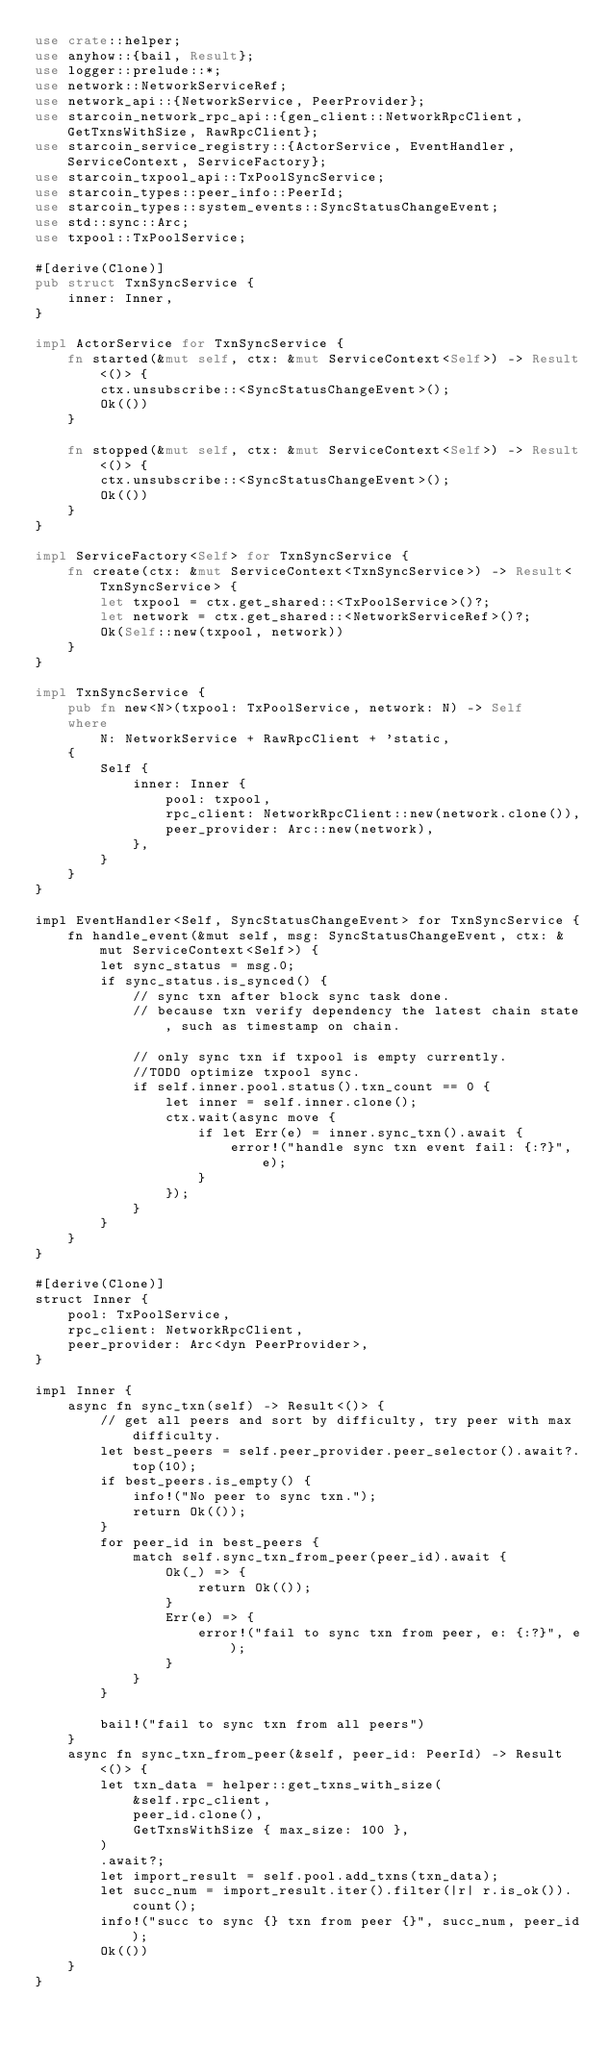<code> <loc_0><loc_0><loc_500><loc_500><_Rust_>use crate::helper;
use anyhow::{bail, Result};
use logger::prelude::*;
use network::NetworkServiceRef;
use network_api::{NetworkService, PeerProvider};
use starcoin_network_rpc_api::{gen_client::NetworkRpcClient, GetTxnsWithSize, RawRpcClient};
use starcoin_service_registry::{ActorService, EventHandler, ServiceContext, ServiceFactory};
use starcoin_txpool_api::TxPoolSyncService;
use starcoin_types::peer_info::PeerId;
use starcoin_types::system_events::SyncStatusChangeEvent;
use std::sync::Arc;
use txpool::TxPoolService;

#[derive(Clone)]
pub struct TxnSyncService {
    inner: Inner,
}

impl ActorService for TxnSyncService {
    fn started(&mut self, ctx: &mut ServiceContext<Self>) -> Result<()> {
        ctx.unsubscribe::<SyncStatusChangeEvent>();
        Ok(())
    }

    fn stopped(&mut self, ctx: &mut ServiceContext<Self>) -> Result<()> {
        ctx.unsubscribe::<SyncStatusChangeEvent>();
        Ok(())
    }
}

impl ServiceFactory<Self> for TxnSyncService {
    fn create(ctx: &mut ServiceContext<TxnSyncService>) -> Result<TxnSyncService> {
        let txpool = ctx.get_shared::<TxPoolService>()?;
        let network = ctx.get_shared::<NetworkServiceRef>()?;
        Ok(Self::new(txpool, network))
    }
}

impl TxnSyncService {
    pub fn new<N>(txpool: TxPoolService, network: N) -> Self
    where
        N: NetworkService + RawRpcClient + 'static,
    {
        Self {
            inner: Inner {
                pool: txpool,
                rpc_client: NetworkRpcClient::new(network.clone()),
                peer_provider: Arc::new(network),
            },
        }
    }
}

impl EventHandler<Self, SyncStatusChangeEvent> for TxnSyncService {
    fn handle_event(&mut self, msg: SyncStatusChangeEvent, ctx: &mut ServiceContext<Self>) {
        let sync_status = msg.0;
        if sync_status.is_synced() {
            // sync txn after block sync task done.
            // because txn verify dependency the latest chain state, such as timestamp on chain.

            // only sync txn if txpool is empty currently.
            //TODO optimize txpool sync.
            if self.inner.pool.status().txn_count == 0 {
                let inner = self.inner.clone();
                ctx.wait(async move {
                    if let Err(e) = inner.sync_txn().await {
                        error!("handle sync txn event fail: {:?}", e);
                    }
                });
            }
        }
    }
}

#[derive(Clone)]
struct Inner {
    pool: TxPoolService,
    rpc_client: NetworkRpcClient,
    peer_provider: Arc<dyn PeerProvider>,
}

impl Inner {
    async fn sync_txn(self) -> Result<()> {
        // get all peers and sort by difficulty, try peer with max difficulty.
        let best_peers = self.peer_provider.peer_selector().await?.top(10);
        if best_peers.is_empty() {
            info!("No peer to sync txn.");
            return Ok(());
        }
        for peer_id in best_peers {
            match self.sync_txn_from_peer(peer_id).await {
                Ok(_) => {
                    return Ok(());
                }
                Err(e) => {
                    error!("fail to sync txn from peer, e: {:?}", e);
                }
            }
        }

        bail!("fail to sync txn from all peers")
    }
    async fn sync_txn_from_peer(&self, peer_id: PeerId) -> Result<()> {
        let txn_data = helper::get_txns_with_size(
            &self.rpc_client,
            peer_id.clone(),
            GetTxnsWithSize { max_size: 100 },
        )
        .await?;
        let import_result = self.pool.add_txns(txn_data);
        let succ_num = import_result.iter().filter(|r| r.is_ok()).count();
        info!("succ to sync {} txn from peer {}", succ_num, peer_id);
        Ok(())
    }
}
</code> 